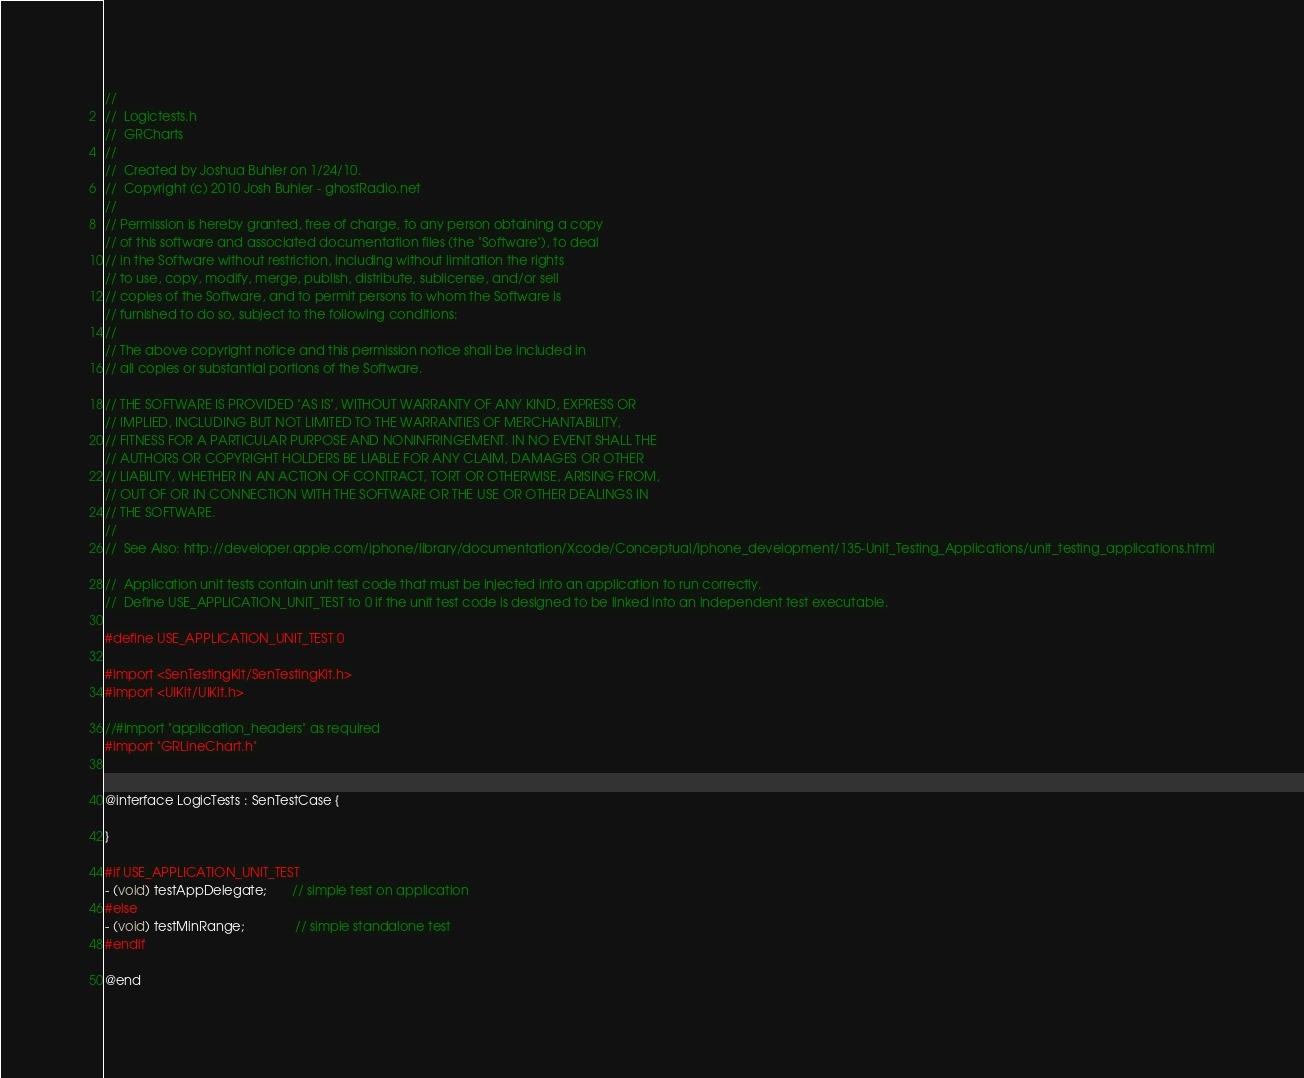Convert code to text. <code><loc_0><loc_0><loc_500><loc_500><_C_>//
//  Logictests.h
//  GRCharts
//
//  Created by Joshua Buhler on 1/24/10.
//  Copyright (c) 2010 Josh Buhler - ghostRadio.net
// 
// Permission is hereby granted, free of charge, to any person obtaining a copy
// of this software and associated documentation files (the "Software"), to deal
// in the Software without restriction, including without limitation the rights
// to use, copy, modify, merge, publish, distribute, sublicense, and/or sell
// copies of the Software, and to permit persons to whom the Software is
// furnished to do so, subject to the following conditions:
// 
// The above copyright notice and this permission notice shall be included in
// all copies or substantial portions of the Software.

// THE SOFTWARE IS PROVIDED "AS IS", WITHOUT WARRANTY OF ANY KIND, EXPRESS OR
// IMPLIED, INCLUDING BUT NOT LIMITED TO THE WARRANTIES OF MERCHANTABILITY,
// FITNESS FOR A PARTICULAR PURPOSE AND NONINFRINGEMENT. IN NO EVENT SHALL THE
// AUTHORS OR COPYRIGHT HOLDERS BE LIABLE FOR ANY CLAIM, DAMAGES OR OTHER
// LIABILITY, WHETHER IN AN ACTION OF CONTRACT, TORT OR OTHERWISE, ARISING FROM,
// OUT OF OR IN CONNECTION WITH THE SOFTWARE OR THE USE OR OTHER DEALINGS IN
// THE SOFTWARE.
//
//  See Also: http://developer.apple.com/iphone/library/documentation/Xcode/Conceptual/iphone_development/135-Unit_Testing_Applications/unit_testing_applications.html

//  Application unit tests contain unit test code that must be injected into an application to run correctly.
//  Define USE_APPLICATION_UNIT_TEST to 0 if the unit test code is designed to be linked into an independent test executable.

#define USE_APPLICATION_UNIT_TEST 0

#import <SenTestingKit/SenTestingKit.h>
#import <UIKit/UIKit.h>

//#import "application_headers" as required
#import "GRLineChart.h"


@interface LogicTests : SenTestCase {

}

#if USE_APPLICATION_UNIT_TEST
- (void) testAppDelegate;       // simple test on application
#else
- (void) testMinRange;              // simple standalone test
#endif

@end
</code> 